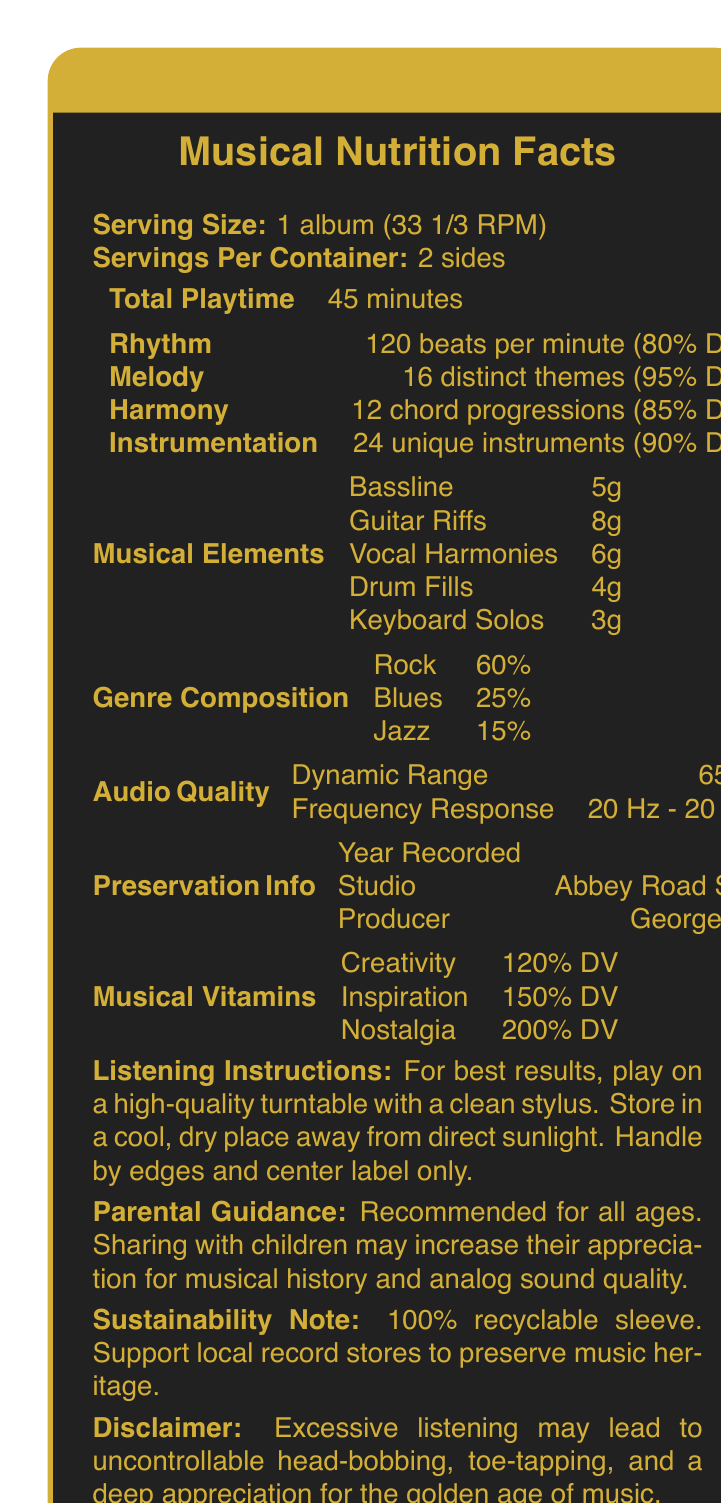what is the serving size of the Vintage Vinyl Symphony album? The serving size is explicitly mentioned as 1 album (33 1/3 RPM) in the document.
Answer: 1 album (33 1/3 RPM) how many unique instruments are listed in the Instrumentation section? The Instrumentation section states there are 24 unique instruments with a daily value of 90%.
Answer: 24 unique instruments what is the total playtime of the album? The Total Playtime is listed as 45 minutes in the document.
Answer: 45 minutes who produced the Vintage Vinyl Symphony? The Producer is indicated as George Martin in the Preservation Info section.
Answer: George Martin what percentage of the composition is rock music? The Genre Composition section shows that rock music makes up 60% of the album.
Answer: 60% how many distinct themes are in the melody? The Melody section states there are 16 distinct themes with a daily value of 95%.
Answer: 16 distinct themes what is the dynamic range of the audio quality? A. 60 dB B. 65 dB C. 70 dB D. 75 dB The Audio Quality section lists the dynamic range as 65 dB.
Answer: B which musical element has the highest amount? I. Bassline II. Guitar Riffs III. Drum Fills IV. Keyboard Solos In the Musical Elements section, Guitar Riffs is the highest amount with 8g.
Answer: II did George Martin record the album in Abbey Road Studios? The Preservation Info section indicates the album was recorded at Abbey Road Studios and produced by George Martin.
Answer: Yes describe the main idea of this document. The document primarily focuses on presenting the musical features and preservation details of the "Vintage Vinyl Symphony" in the format of a nutrition facts label, highlighting its musical history and the benefits of analog sound.
Answer: This document is a nutrition facts label for a vintage vinyl record named "Vintage Vinyl Symphony." It creatively lists musical nutrients such as rhythm, melody, and harmony, alongside the album's genre composition, audio quality, preservation info, musical vitamins, and listening instructions. It emphasizes the analog music experience and encourages sharing it with children. how many servings are per container? The document states that there are 2 sides, which implies 2 servings per container.
Answer: 2 sides what year was the Vintage Vinyl Symphony recorded? The Preservation Info section lists the year recorded as 1972.
Answer: 1972 what are the daily values of creativity, inspiration, and nostalgia collectively? Adding the daily values from the Musical Vitamins section, Creativity (120%), Inspiration (150%), and Nostalgia (200%) gives a total of 470%.
Answer: 470% which of the following is not a musical nutrient? 1. Rhythm 2. Melody 3. Bassline 4. Harmony Bassline is listed under Musical Elements, not Musical Nutrients.
Answer: 3 how many distinct themes contribute to the melody's daily value? The Melody section specifies 16 distinct themes contributing to its daily value of 95%.
Answer: 16 distinct themes how should you handle the album to ensure it remains in good condition? The Listening Instructions section advises handling the album by edges and center label only to preserve its condition.
Answer: Handle by edges and center label only is it possible to determine the exact price of the Vintage Vinyl Symphony from this document? The document does not provide any information regarding the price of the Vintage Vinyl Symphony.
Answer: Cannot be determined 